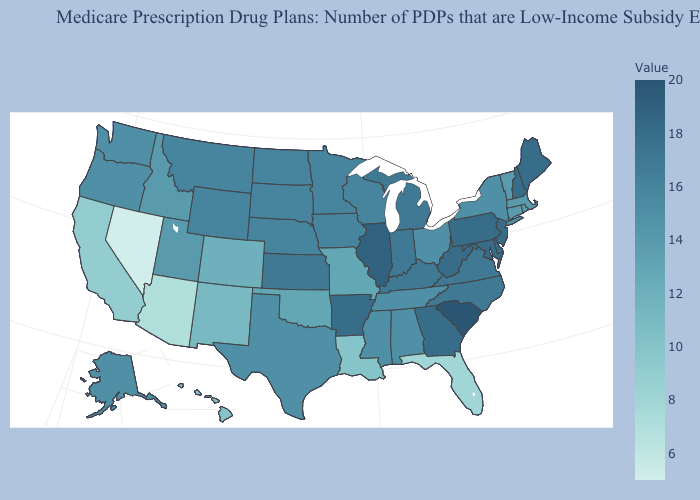Which states hav the highest value in the MidWest?
Be succinct. Illinois. Which states hav the highest value in the South?
Write a very short answer. South Carolina. Which states have the lowest value in the USA?
Answer briefly. Nevada. Among the states that border Mississippi , does Louisiana have the lowest value?
Quick response, please. Yes. Does Tennessee have a higher value than Maine?
Concise answer only. No. Which states have the lowest value in the USA?
Write a very short answer. Nevada. Does Wisconsin have a higher value than Hawaii?
Give a very brief answer. Yes. 